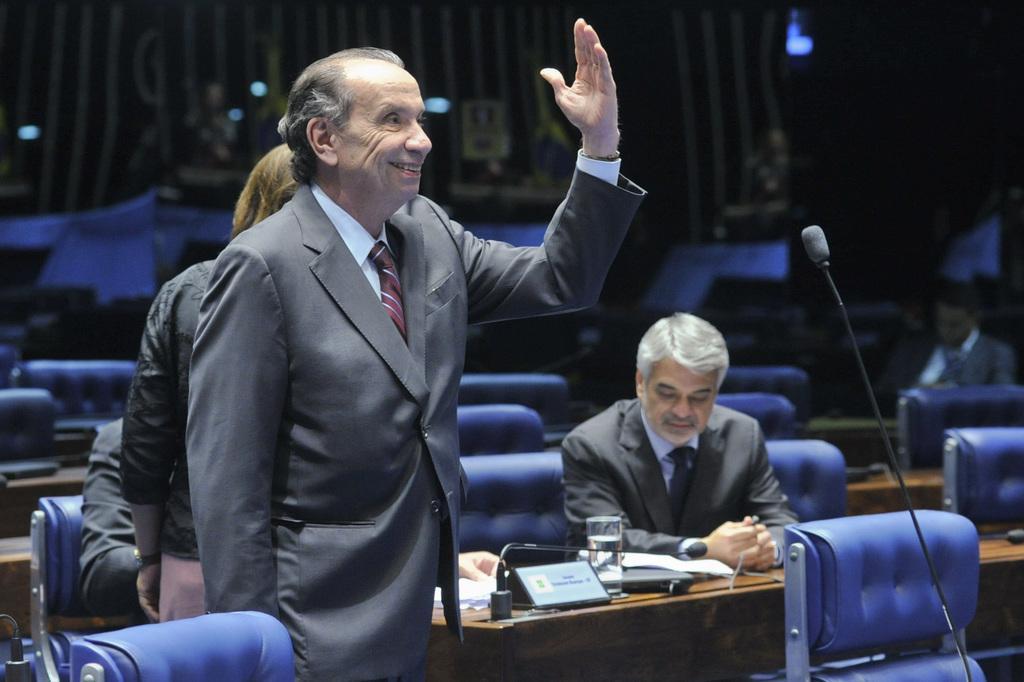Describe this image in one or two sentences. In front of the image there is a person standing, behind him there is a woman, in the background of the image there are a few people sitting in chairs and there are some empty chairs as well, on the tables there are some objects, in front of the person there is a mic, in the background of the image there are a few objects and there is a design on the wall. 